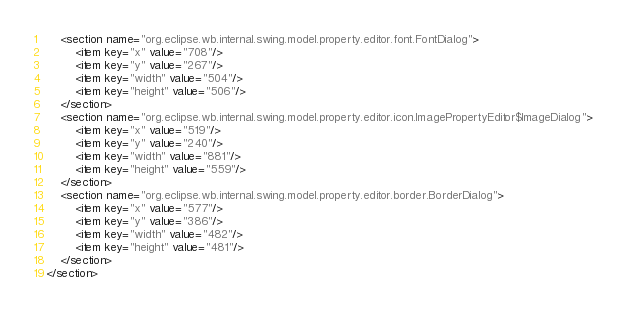Convert code to text. <code><loc_0><loc_0><loc_500><loc_500><_XML_>	<section name="org.eclipse.wb.internal.swing.model.property.editor.font.FontDialog">
		<item key="x" value="708"/>
		<item key="y" value="267"/>
		<item key="width" value="504"/>
		<item key="height" value="506"/>
	</section>
	<section name="org.eclipse.wb.internal.swing.model.property.editor.icon.ImagePropertyEditor$ImageDialog">
		<item key="x" value="519"/>
		<item key="y" value="240"/>
		<item key="width" value="881"/>
		<item key="height" value="559"/>
	</section>
	<section name="org.eclipse.wb.internal.swing.model.property.editor.border.BorderDialog">
		<item key="x" value="577"/>
		<item key="y" value="386"/>
		<item key="width" value="482"/>
		<item key="height" value="481"/>
	</section>
</section>
</code> 